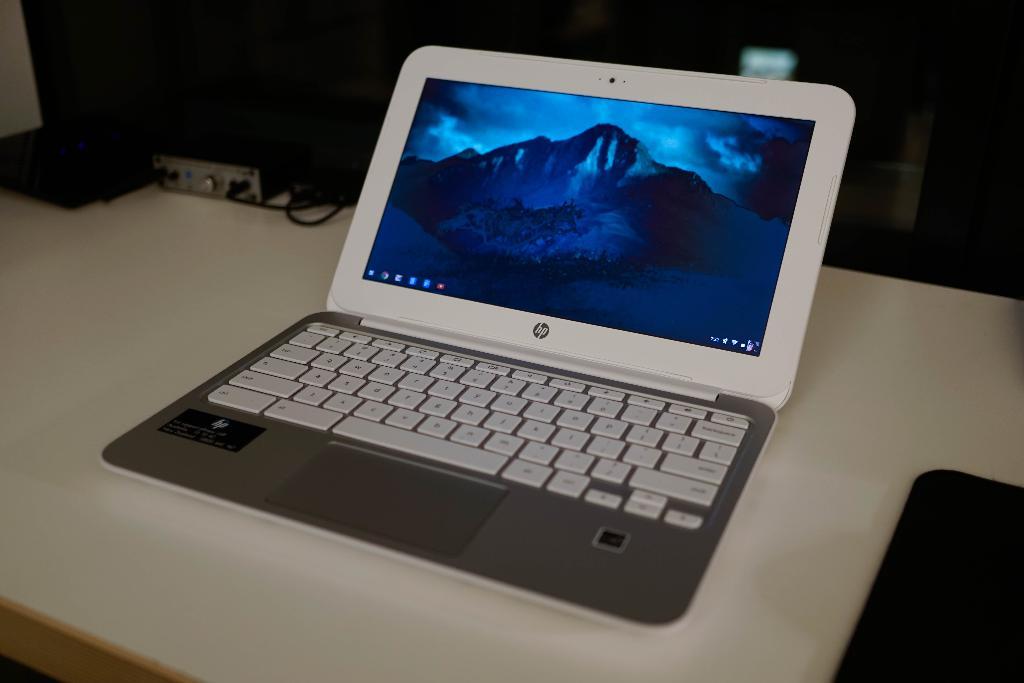What brand is the laptop?
Provide a succinct answer. Hp. 